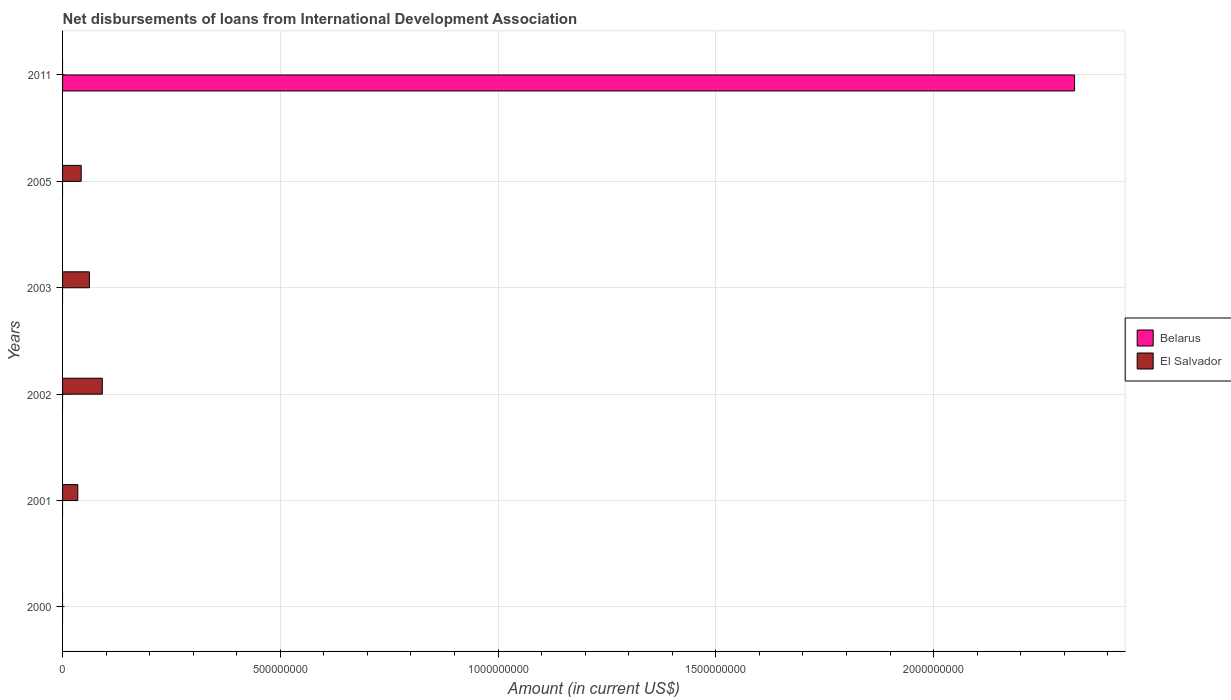Are the number of bars on each tick of the Y-axis equal?
Ensure brevity in your answer.  No. How many bars are there on the 1st tick from the top?
Offer a very short reply. 1. How many bars are there on the 5th tick from the bottom?
Provide a short and direct response. 1. In how many cases, is the number of bars for a given year not equal to the number of legend labels?
Offer a very short reply. 6. What is the amount of loans disbursed in El Salvador in 2001?
Ensure brevity in your answer.  3.50e+07. Across all years, what is the maximum amount of loans disbursed in El Salvador?
Give a very brief answer. 9.13e+07. In which year was the amount of loans disbursed in Belarus maximum?
Your response must be concise. 2011. What is the total amount of loans disbursed in Belarus in the graph?
Keep it short and to the point. 2.32e+09. What is the difference between the amount of loans disbursed in El Salvador in 2001 and that in 2003?
Provide a short and direct response. -2.66e+07. What is the difference between the amount of loans disbursed in El Salvador in 2001 and the amount of loans disbursed in Belarus in 2002?
Offer a very short reply. 3.50e+07. What is the average amount of loans disbursed in Belarus per year?
Offer a very short reply. 3.87e+08. In how many years, is the amount of loans disbursed in El Salvador greater than 2200000000 US$?
Your answer should be very brief. 0. What is the ratio of the amount of loans disbursed in El Salvador in 2002 to that in 2005?
Provide a succinct answer. 2.13. What is the difference between the highest and the second highest amount of loans disbursed in El Salvador?
Your answer should be compact. 2.97e+07. What is the difference between the highest and the lowest amount of loans disbursed in El Salvador?
Your response must be concise. 9.13e+07. How many bars are there?
Offer a terse response. 5. Are all the bars in the graph horizontal?
Offer a very short reply. Yes. What is the difference between two consecutive major ticks on the X-axis?
Give a very brief answer. 5.00e+08. How are the legend labels stacked?
Make the answer very short. Vertical. What is the title of the graph?
Offer a very short reply. Net disbursements of loans from International Development Association. Does "Channel Islands" appear as one of the legend labels in the graph?
Make the answer very short. No. What is the Amount (in current US$) in El Salvador in 2000?
Your answer should be very brief. 0. What is the Amount (in current US$) of Belarus in 2001?
Your response must be concise. 0. What is the Amount (in current US$) of El Salvador in 2001?
Your answer should be compact. 3.50e+07. What is the Amount (in current US$) of Belarus in 2002?
Your answer should be compact. 0. What is the Amount (in current US$) in El Salvador in 2002?
Give a very brief answer. 9.13e+07. What is the Amount (in current US$) of El Salvador in 2003?
Your answer should be compact. 6.16e+07. What is the Amount (in current US$) of Belarus in 2005?
Your answer should be very brief. 0. What is the Amount (in current US$) of El Salvador in 2005?
Give a very brief answer. 4.28e+07. What is the Amount (in current US$) of Belarus in 2011?
Ensure brevity in your answer.  2.32e+09. Across all years, what is the maximum Amount (in current US$) of Belarus?
Keep it short and to the point. 2.32e+09. Across all years, what is the maximum Amount (in current US$) in El Salvador?
Give a very brief answer. 9.13e+07. What is the total Amount (in current US$) of Belarus in the graph?
Make the answer very short. 2.32e+09. What is the total Amount (in current US$) of El Salvador in the graph?
Provide a short and direct response. 2.31e+08. What is the difference between the Amount (in current US$) in El Salvador in 2001 and that in 2002?
Your response must be concise. -5.63e+07. What is the difference between the Amount (in current US$) of El Salvador in 2001 and that in 2003?
Your response must be concise. -2.66e+07. What is the difference between the Amount (in current US$) of El Salvador in 2001 and that in 2005?
Give a very brief answer. -7.81e+06. What is the difference between the Amount (in current US$) of El Salvador in 2002 and that in 2003?
Offer a very short reply. 2.97e+07. What is the difference between the Amount (in current US$) in El Salvador in 2002 and that in 2005?
Provide a short and direct response. 4.85e+07. What is the difference between the Amount (in current US$) in El Salvador in 2003 and that in 2005?
Provide a short and direct response. 1.88e+07. What is the average Amount (in current US$) in Belarus per year?
Ensure brevity in your answer.  3.87e+08. What is the average Amount (in current US$) in El Salvador per year?
Make the answer very short. 3.84e+07. What is the ratio of the Amount (in current US$) in El Salvador in 2001 to that in 2002?
Give a very brief answer. 0.38. What is the ratio of the Amount (in current US$) in El Salvador in 2001 to that in 2003?
Your response must be concise. 0.57. What is the ratio of the Amount (in current US$) of El Salvador in 2001 to that in 2005?
Provide a succinct answer. 0.82. What is the ratio of the Amount (in current US$) in El Salvador in 2002 to that in 2003?
Your response must be concise. 1.48. What is the ratio of the Amount (in current US$) in El Salvador in 2002 to that in 2005?
Provide a short and direct response. 2.13. What is the ratio of the Amount (in current US$) of El Salvador in 2003 to that in 2005?
Give a very brief answer. 1.44. What is the difference between the highest and the second highest Amount (in current US$) in El Salvador?
Your answer should be very brief. 2.97e+07. What is the difference between the highest and the lowest Amount (in current US$) in Belarus?
Ensure brevity in your answer.  2.32e+09. What is the difference between the highest and the lowest Amount (in current US$) of El Salvador?
Offer a very short reply. 9.13e+07. 